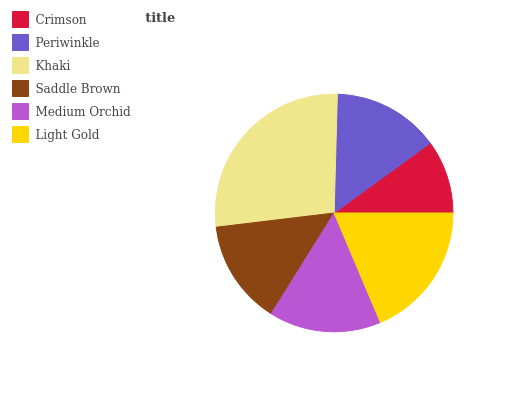Is Crimson the minimum?
Answer yes or no. Yes. Is Khaki the maximum?
Answer yes or no. Yes. Is Periwinkle the minimum?
Answer yes or no. No. Is Periwinkle the maximum?
Answer yes or no. No. Is Periwinkle greater than Crimson?
Answer yes or no. Yes. Is Crimson less than Periwinkle?
Answer yes or no. Yes. Is Crimson greater than Periwinkle?
Answer yes or no. No. Is Periwinkle less than Crimson?
Answer yes or no. No. Is Medium Orchid the high median?
Answer yes or no. Yes. Is Periwinkle the low median?
Answer yes or no. Yes. Is Saddle Brown the high median?
Answer yes or no. No. Is Saddle Brown the low median?
Answer yes or no. No. 